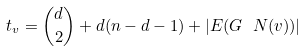Convert formula to latex. <formula><loc_0><loc_0><loc_500><loc_500>t _ { v } = \binom { d } { 2 } + d ( n - d - 1 ) + | E ( G \ N ( v ) ) |</formula> 